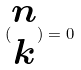Convert formula to latex. <formula><loc_0><loc_0><loc_500><loc_500>( \begin{matrix} n \\ k \end{matrix} ) = 0</formula> 